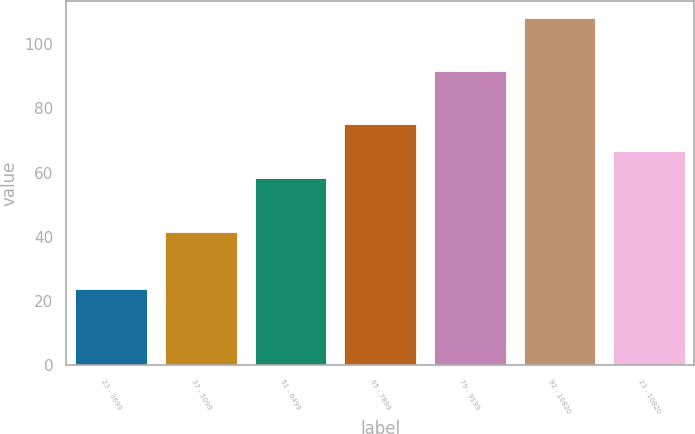Convert chart. <chart><loc_0><loc_0><loc_500><loc_500><bar_chart><fcel>23 - 3699<fcel>37 - 5099<fcel>51 - 6499<fcel>65 - 7899<fcel>79 - 9199<fcel>92 - 10820<fcel>23 - 10820<nl><fcel>23.66<fcel>41.4<fcel>58.18<fcel>75.08<fcel>91.81<fcel>108.2<fcel>66.63<nl></chart> 